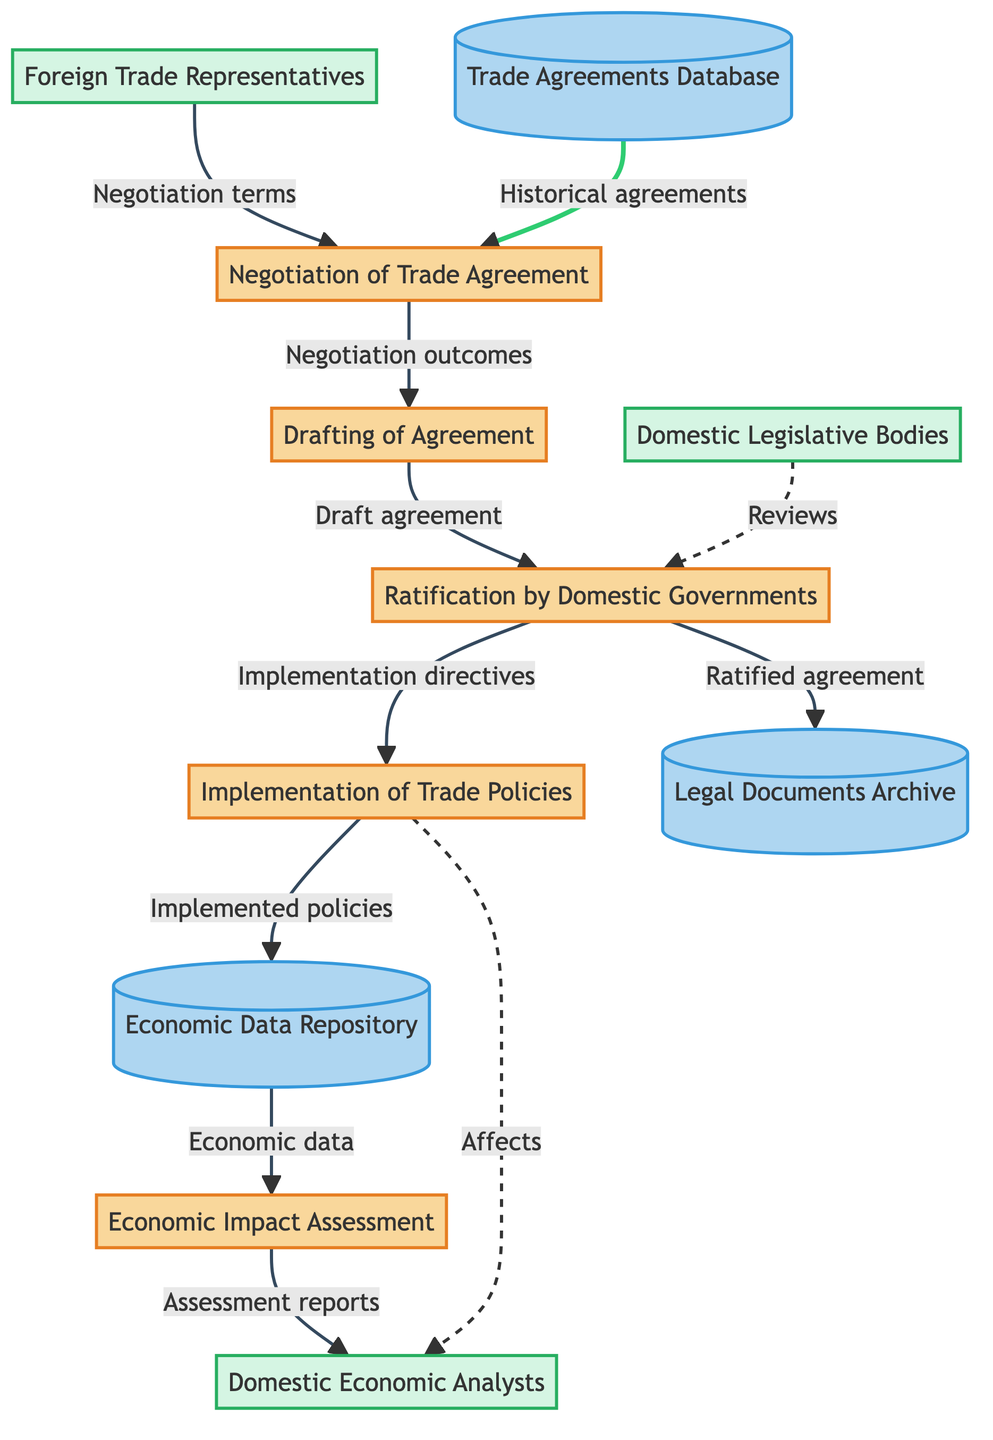What is the first process in the diagram? The first process is identified as "Negotiation of Trade Agreement," which is where diplomats and trade representatives negotiate the terms of trade. Since this process starts the workflow, it is clearly labeled first in the diagram.
Answer: Negotiation of Trade Agreement How many external entities are present in the diagram? The diagram includes three external entities: Foreign Trade Representatives, Domestic Legislative Bodies, and Domestic Economic Analysts. Counting these entities gives the total number.
Answer: 3 What data store receives the ratified agreement? The ratified agreement is sent to the "Legal Documents Archive," which stores all legal documents associated with trade agreements. This link is explicitly shown in the flow of the diagram.
Answer: Legal Documents Archive Which process comes after drafting of the agreement? The process that follows "Drafting of Agreement" is "Ratification by Domestic Governments." This is shown by the arrow leading from the drafting process to the ratification process in the flow.
Answer: Ratification by Domestic Governments What do domestic legislative bodies do according to the diagram? Domestic legislative bodies are responsible for reviewing and ratifying the trade agreements. This function is linked to them within the "Ratification by Domestic Governments" process.
Answer: Ratifying Which data store is directly affected by the implementation of trade policies? The data store affected by the implementation of trade policies is the "Economic Data Repository." This is indicated by the flow from the implementation process to the data store.
Answer: Economic Data Repository What type of report do domestic economic analysts receive? Domestic economic analysts receive "Assessment reports" from the Economic Impact Assessment process, and this is indicated by the flow from the assessment to the analysts in the diagram.
Answer: Assessment reports How are historical agreements referenced in the negotiation process? Historical agreements are referenced in the negotiation process through the "Trade Agreements Database," which provides context and background for the current negotiations. This relationship is shown with an arrow pointing from the data store to the negotiation process.
Answer: Trade Agreements Database What is the main outcome of the economic impact assessment? The main outcome of the economic impact assessment is "Assessment reports" that summarize the evaluation of the trade agreement's effects on the domestic economy. This is connected to domestic economic analysts in the diagram.
Answer: Assessment reports 